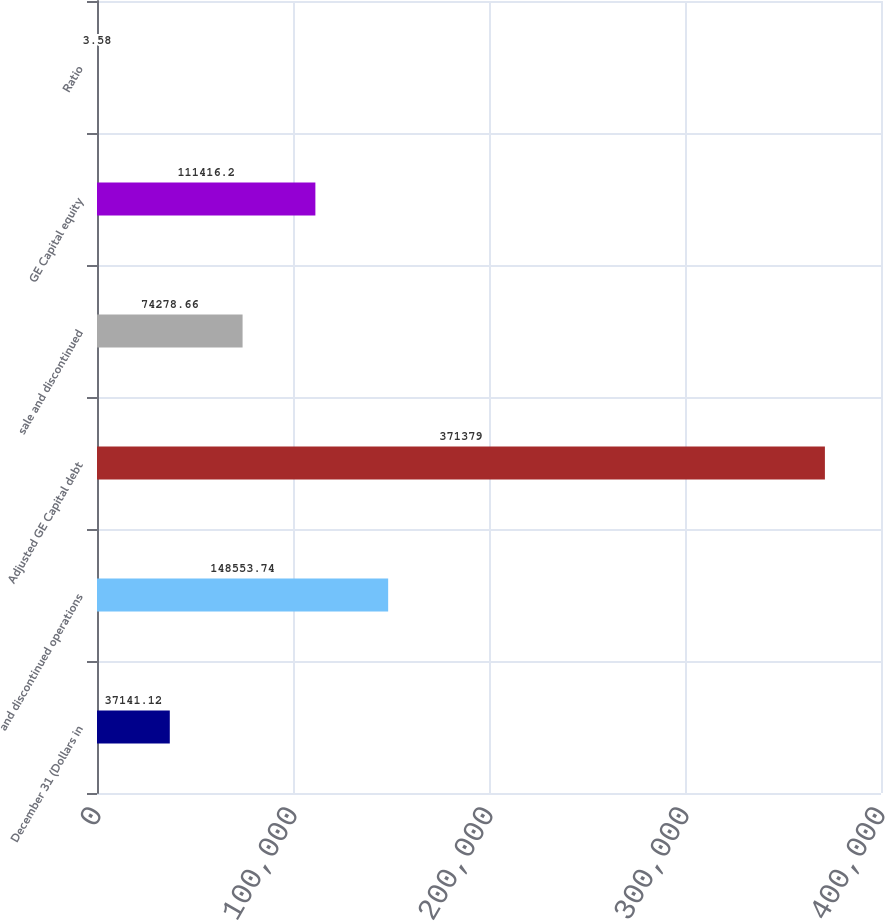Convert chart to OTSL. <chart><loc_0><loc_0><loc_500><loc_500><bar_chart><fcel>December 31 (Dollars in<fcel>and discontinued operations<fcel>Adjusted GE Capital debt<fcel>sale and discontinued<fcel>GE Capital equity<fcel>Ratio<nl><fcel>37141.1<fcel>148554<fcel>371379<fcel>74278.7<fcel>111416<fcel>3.58<nl></chart> 